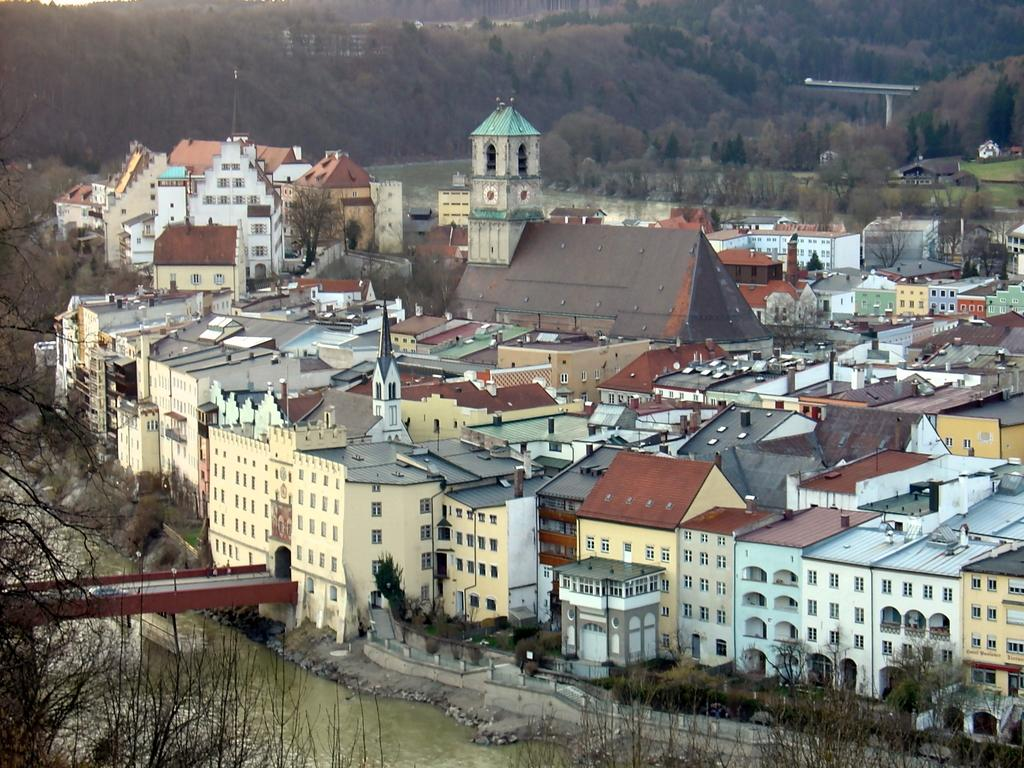What type of structures can be seen in the image? There are many houses and buildings in the image. What is the bridge in the image used for? The bridge in the image is used to cross a river. Where is the bridge located in relation to the buildings? The bridge is in front of the buildings in the image. What can be found around the river in the image? There are many trees around the river in the image. What type of pest can be seen crawling on the bridge in the image? There are no pests visible on the bridge in the image. What type of bird is perched on the trees near the river in the image? There is no bird mentioned or visible in the image. 